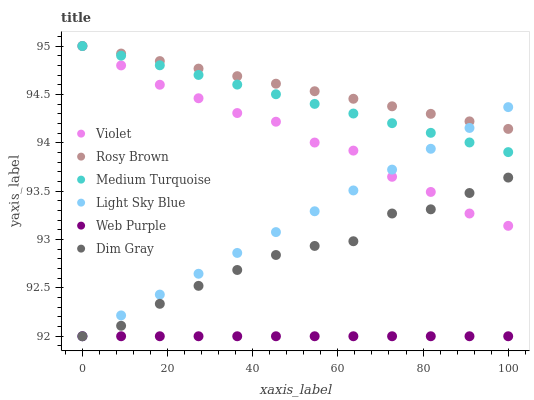Does Web Purple have the minimum area under the curve?
Answer yes or no. Yes. Does Rosy Brown have the maximum area under the curve?
Answer yes or no. Yes. Does Rosy Brown have the minimum area under the curve?
Answer yes or no. No. Does Web Purple have the maximum area under the curve?
Answer yes or no. No. Is Web Purple the smoothest?
Answer yes or no. Yes. Is Dim Gray the roughest?
Answer yes or no. Yes. Is Rosy Brown the smoothest?
Answer yes or no. No. Is Rosy Brown the roughest?
Answer yes or no. No. Does Dim Gray have the lowest value?
Answer yes or no. Yes. Does Rosy Brown have the lowest value?
Answer yes or no. No. Does Violet have the highest value?
Answer yes or no. Yes. Does Web Purple have the highest value?
Answer yes or no. No. Is Web Purple less than Violet?
Answer yes or no. Yes. Is Violet greater than Web Purple?
Answer yes or no. Yes. Does Web Purple intersect Dim Gray?
Answer yes or no. Yes. Is Web Purple less than Dim Gray?
Answer yes or no. No. Is Web Purple greater than Dim Gray?
Answer yes or no. No. Does Web Purple intersect Violet?
Answer yes or no. No. 